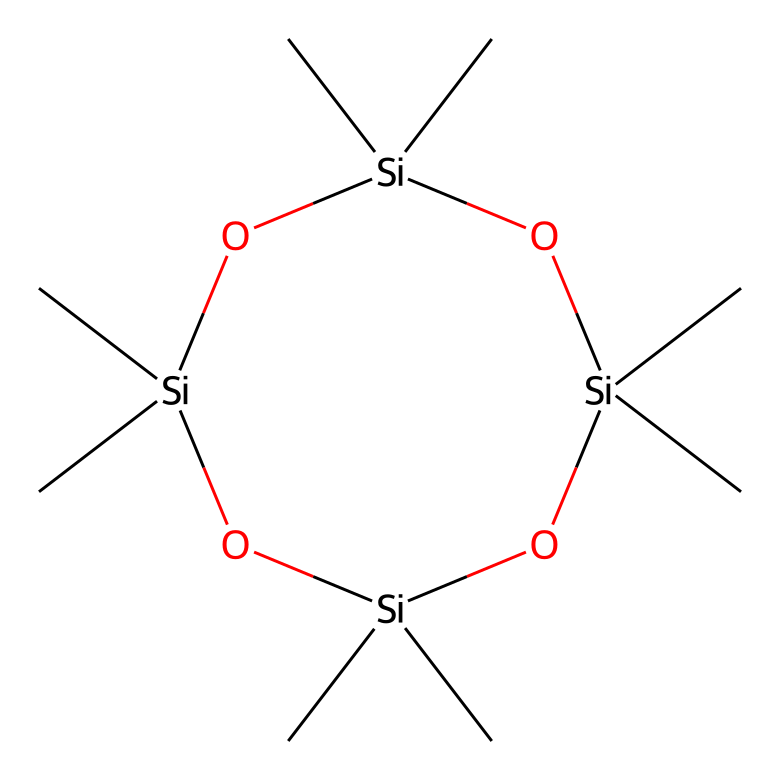How many silicon atoms are in the molecular structure? The SMILES representation reveals the presence of four silicon (Si) atoms that can be counted directly from the structure.
Answer: 4 What is the main functional group in octamethylcyclotetrasiloxane? Analyzing the chemical structure shows that it consists of siloxane linkages (Si-O), which are the primary functional groups present.
Answer: siloxane How many methyl groups are attached to each silicon atom? In the structure, every silicon atom is connected to three methyl (C) groups, as indicated by the branches that extend from each Si atom.
Answer: 3 What is the total number of oxygen atoms in the molecule? The structure contains four oxygen (O) atoms, which can be identified by looking for the oxygen symbols in the SMILES representation.
Answer: 4 Does octamethylcyclotetrasiloxane contain any double bonds? Upon examining the structure, there are no double bonds present; all connections in the siloxane backbone are single bonds.
Answer: no Which type of chemical is octamethylcyclotetrasiloxane primarily classified as? Considering its composition, featuring silicon and oxygen atoms in a cyclic arrangement, it is primarily classified as a siloxane compound.
Answer: siloxane 